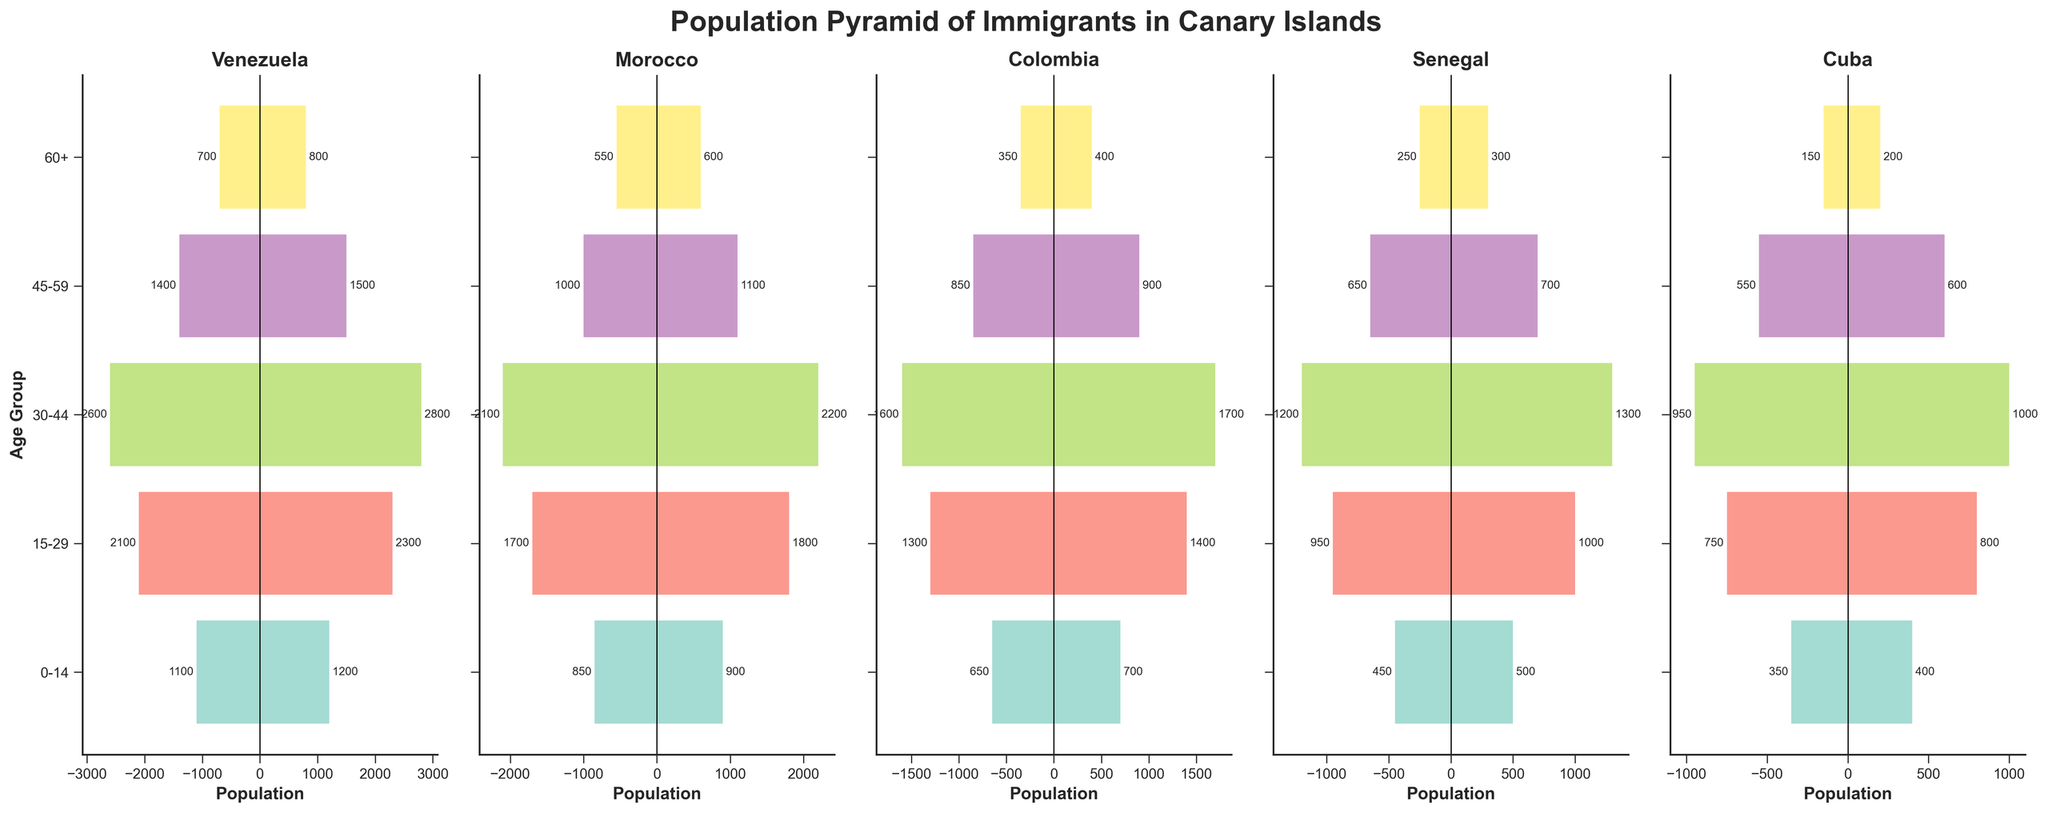Which country has the largest number of male immigrants in the 30-44 age group? Look at the bars representing the 30-44 age group for males in each subplot. The highest bar is for Venezuela with 2800 males.
Answer: Venezuela Which age group has the fewest female immigrants from Senegal? Check the lengths of the bars representing females in each age group for Senegal. The 60+ age group is the shortest with 250 females.
Answer: 60+ Are there more 15-29-year-old immigrants from Morocco or Cuba? Compare the lengths of the bars representing immigrants in the 15-29 age group for Morocco and Cuba. Morocco has 1700 females and 1800 males, while Cuba has 750 females and 800 males. Morocco has more.
Answer: Morocco What's the total number of 0-14-year-old immigrants from Venezuela? Add the number of male and female immigrants in the 0-14 age group for Venezuela: 1200 males + 1100 females = 2300.
Answer: 2300 In the 45-59 age group, which country has an equal number of male and female immigrants? Check the bars representing male and female immigrants in the 45-59 age group in each subplot. No country shows equal numbers; the closest is Cuba where the male count is 600 and female count is 550.
Answer: None How does the gender distribution of 60+ age group immigrants from Morocco compare to those from Colombia? Compare the bars for males and females in the 60+ age group for both countries. Morocco has 600 males and 550 females, Colombia has 400 males and 350 females. Both countries show a similar trend with slightly more males than females.
Answer: Morocco has slightly more males than females; similar for Colombia Which country has the smallest population of immigrants aged 0-14? Compare the lengths of the bars for the 0-14 age group across all countries. Cuba has the smallest with 400 males and 350 females.
Answer: Cuba Are there more female immigrants aged 45-59 from Colombia or Senegal? Compare the lengths of the female bars for the 45-59 age group between Colombia and Senegal. Colombia has 850 and Senegal has 650, so Colombia has more.
Answer: Colombia What's the age group with the highest number of male immigrants overall across all countries? Add up the number of male immigrants in each age group across all countries: 
0-14: 1200(Ven) + 900(Mor) + 700(Col) + 500(Sen) + 400(Cub) = 3700
15-29: 2300(Ven) + 1800(Mor) + 1400(Col) + 1000(Sen) + 800(Cub) = 7300
30-44: 2800(Ven) + 2200(Mor) + 1700(Col) + 1300(Sen) + 1000(Cub) = 9000
45-59: 1500(Ven) + 1100(Mor) + 900(Col) + 700(Sen) + 600(Cub) = 4800
60+: 800(Ven) + 600(Mor) + 400(Col) + 300(Sen) + 200(Cub) = 2300
The 30-44 age group has the highest number of male immigrants overall.
Answer: 30-44 